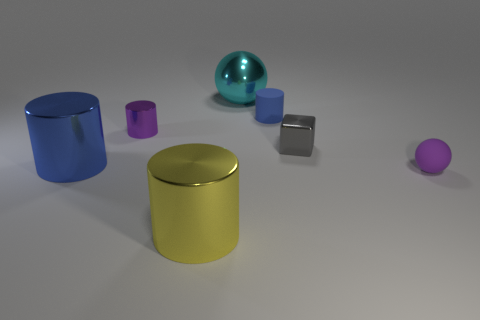What is the color of the large metal ball?
Offer a terse response. Cyan. How many other things are there of the same size as the cyan thing?
Make the answer very short. 2. The small thing that is right of the big cyan metal object and on the left side of the gray shiny object is made of what material?
Ensure brevity in your answer.  Rubber. There is a purple thing in front of the purple cylinder; does it have the same size as the purple metallic cylinder?
Provide a succinct answer. Yes. Does the big metal ball have the same color as the matte ball?
Your answer should be very brief. No. How many objects are both in front of the tiny block and behind the yellow metal thing?
Ensure brevity in your answer.  2. There is a blue matte object behind the tiny rubber thing to the right of the small blue rubber cylinder; what number of blue objects are to the left of it?
Provide a short and direct response. 1. There is a shiny object that is the same color as the tiny matte ball; what is its size?
Ensure brevity in your answer.  Small. There is a blue matte object; what shape is it?
Give a very brief answer. Cylinder. What number of yellow things are made of the same material as the tiny sphere?
Offer a very short reply. 0. 